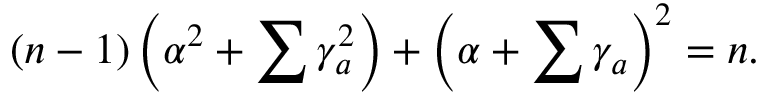<formula> <loc_0><loc_0><loc_500><loc_500>( n - 1 ) \left ( \alpha ^ { 2 } + \sum \gamma _ { a } ^ { 2 } \right ) + \left ( \alpha + \sum \gamma _ { a } \right ) ^ { 2 } = n .</formula> 